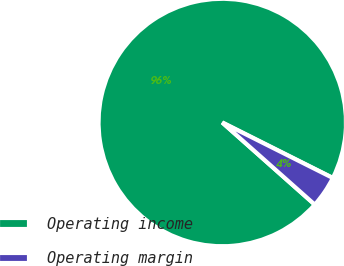Convert chart to OTSL. <chart><loc_0><loc_0><loc_500><loc_500><pie_chart><fcel>Operating income<fcel>Operating margin<nl><fcel>95.85%<fcel>4.15%<nl></chart> 